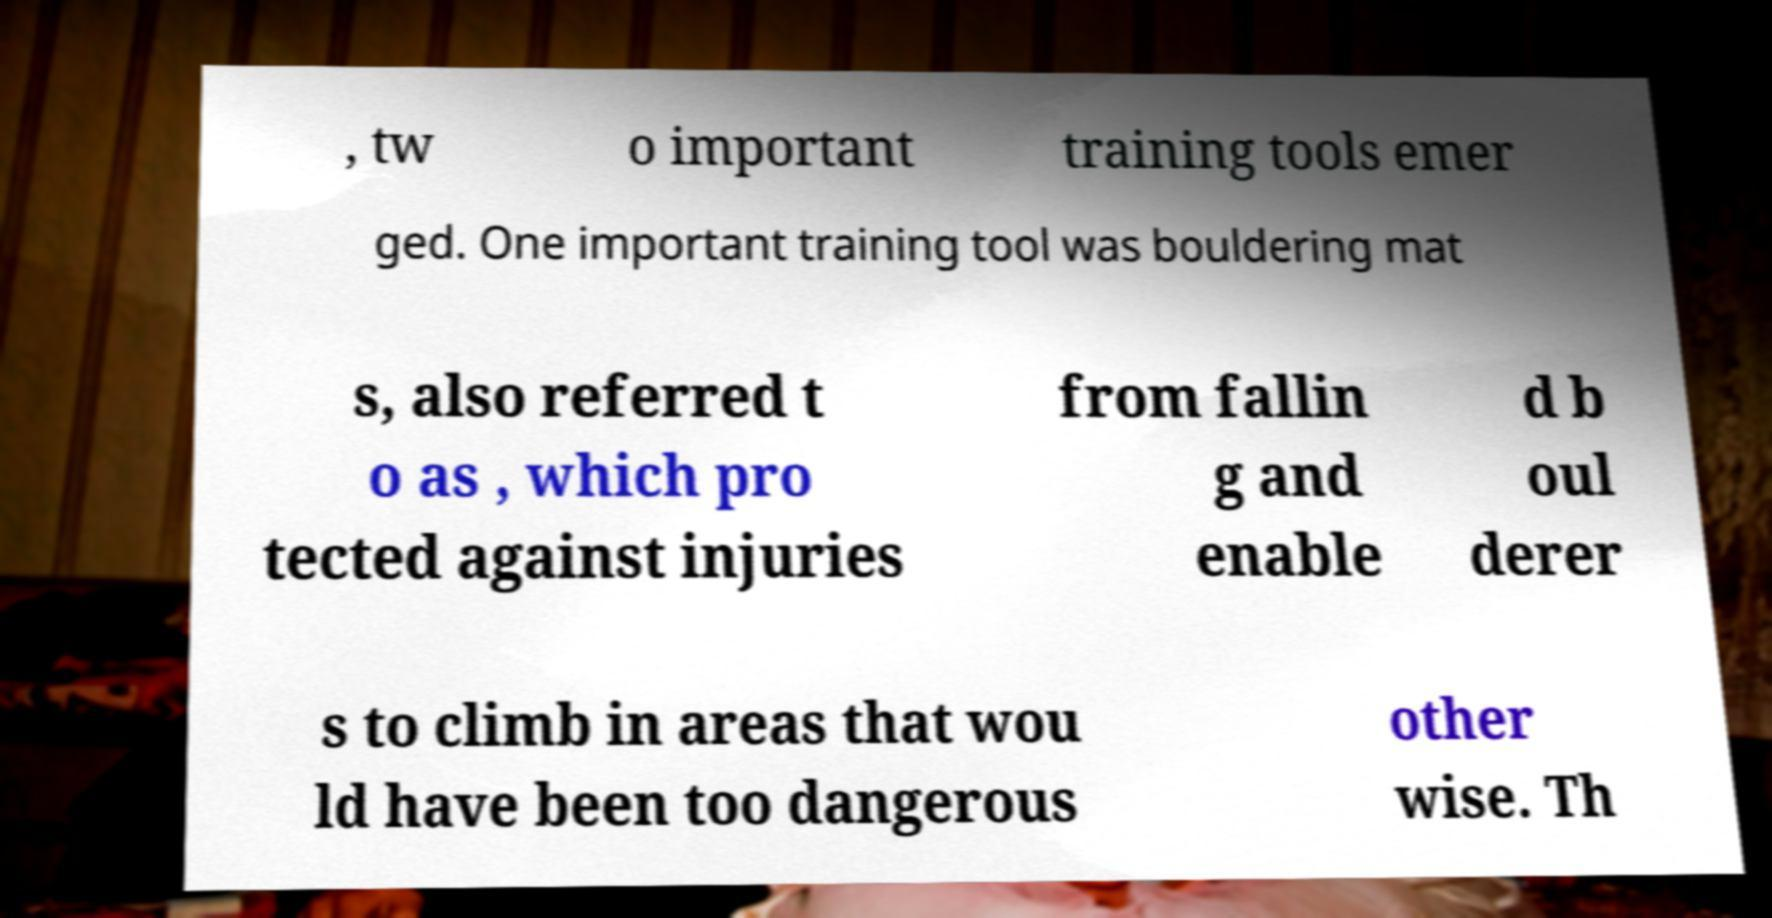What messages or text are displayed in this image? I need them in a readable, typed format. , tw o important training tools emer ged. One important training tool was bouldering mat s, also referred t o as , which pro tected against injuries from fallin g and enable d b oul derer s to climb in areas that wou ld have been too dangerous other wise. Th 